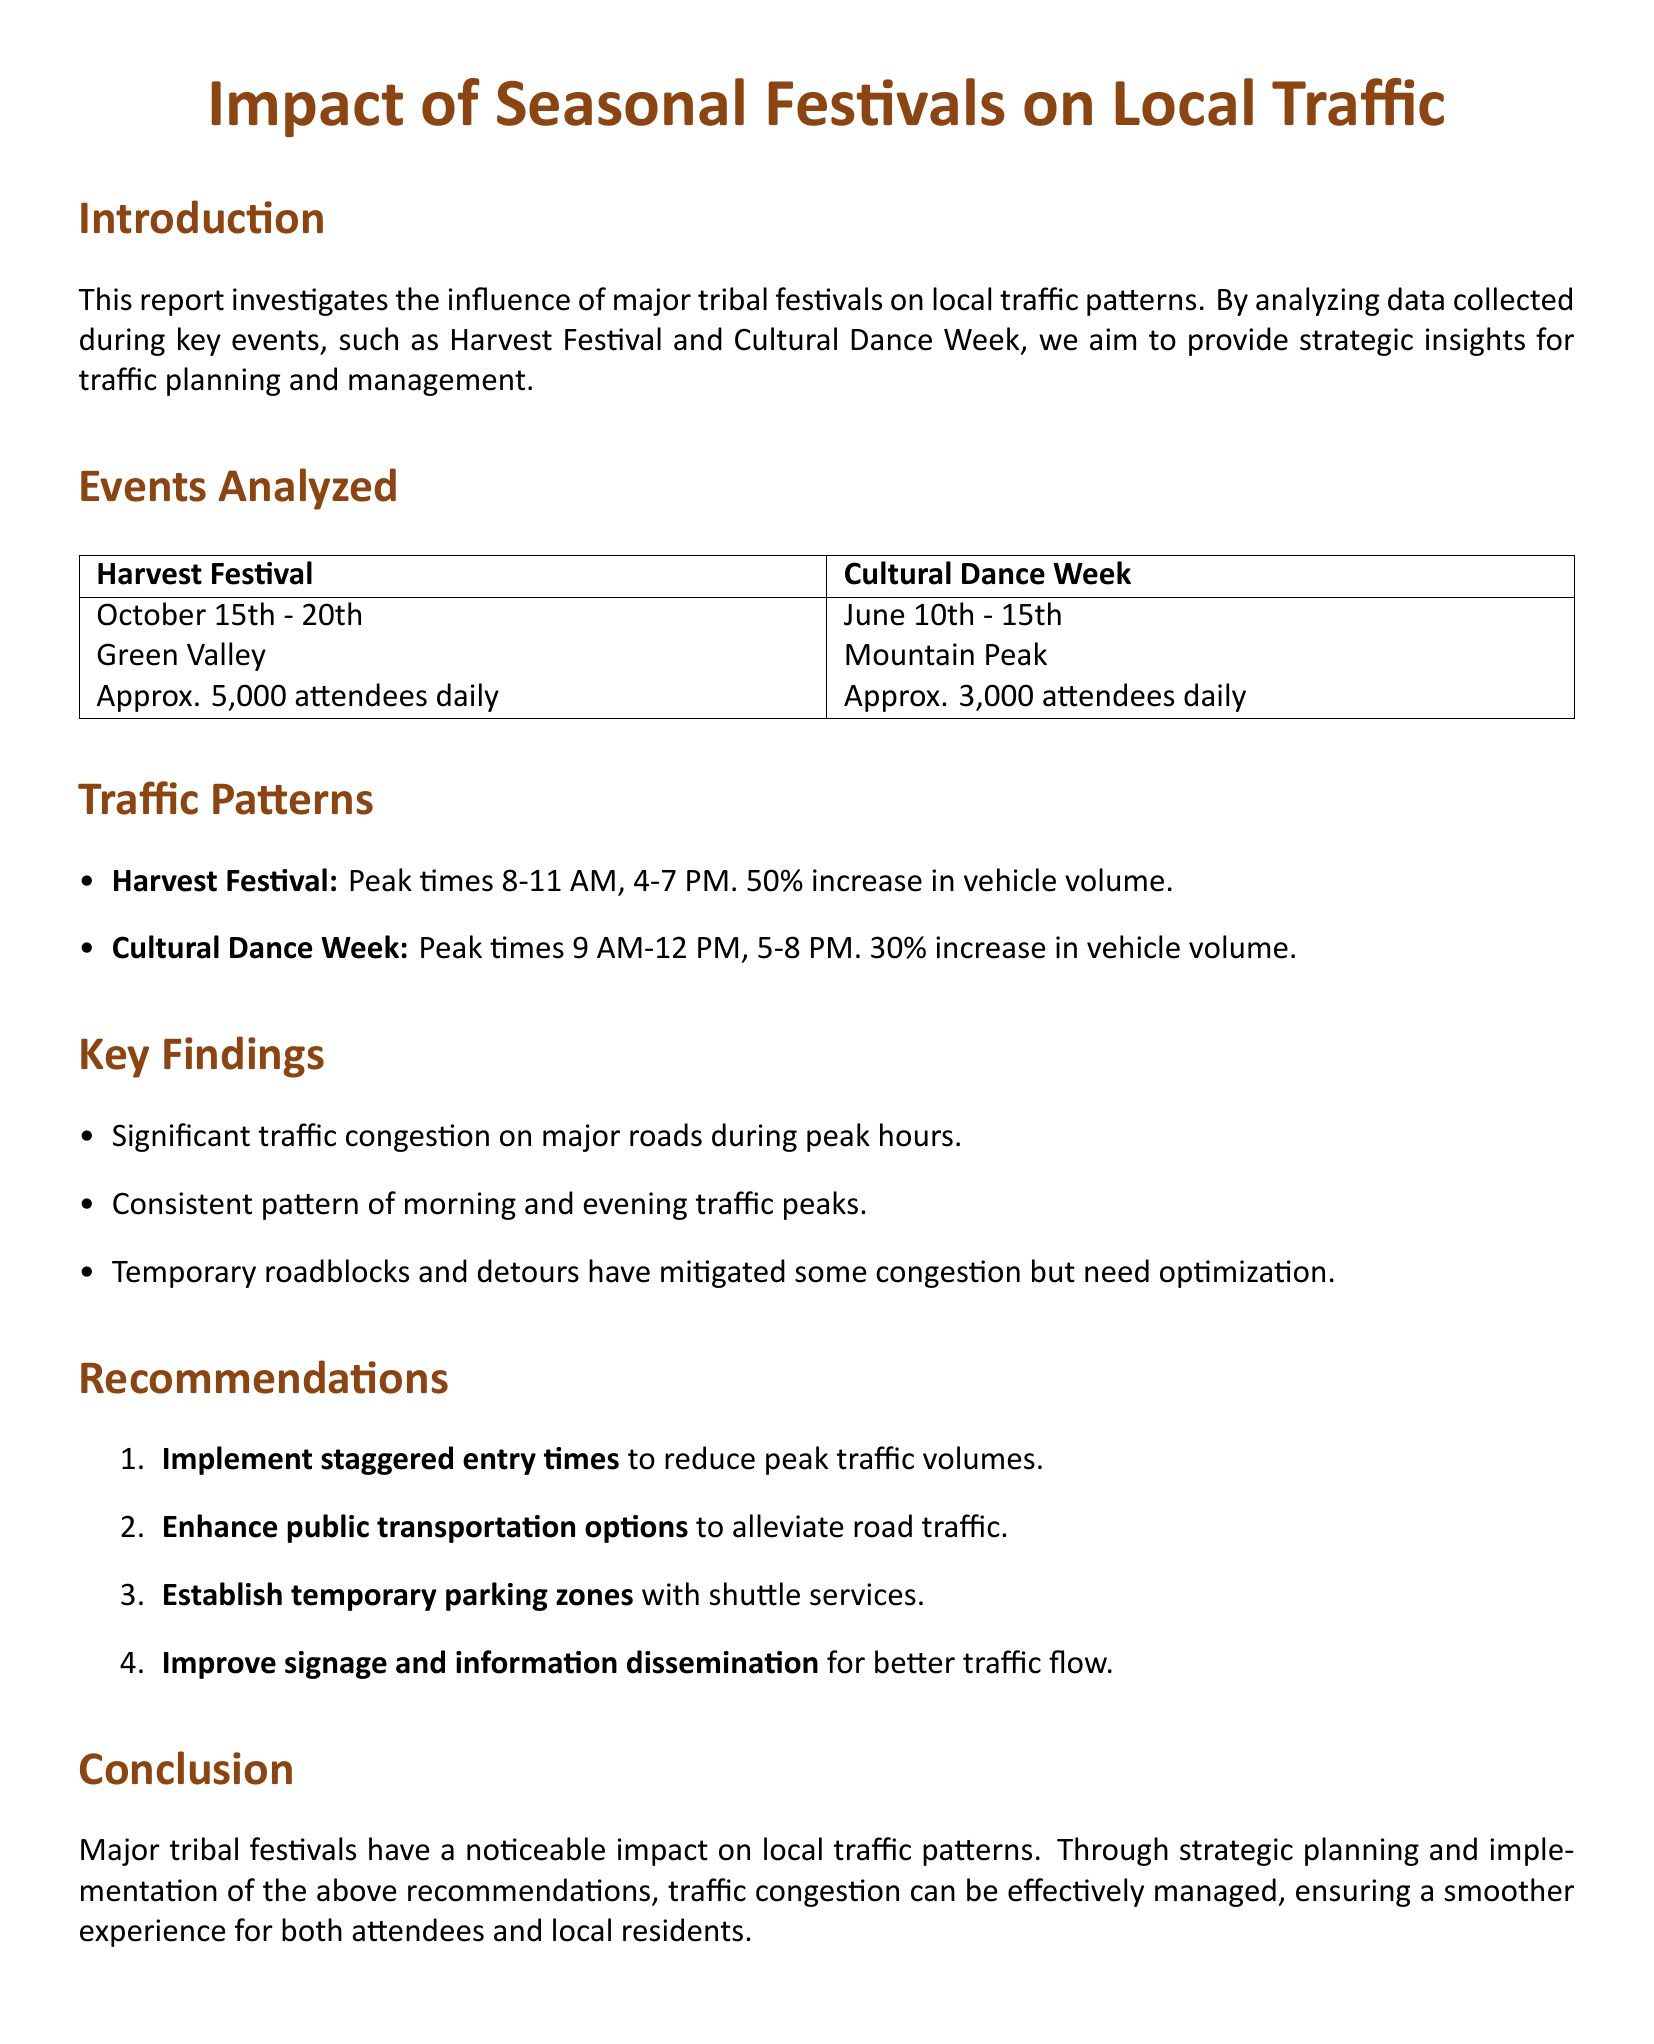What are the dates of the Harvest Festival? The document states that the Harvest Festival occurs from October 15th to 20th.
Answer: October 15th - 20th How many attendees are expected daily during the Cultural Dance Week? According to the report, approximately 3,000 attendees are expected daily during the Cultural Dance Week.
Answer: Approx. 3,000 attendees daily What is the peak time for traffic during the Harvest Festival? The report indicates that the peak traffic times during the Harvest Festival are between 8-11 AM and 4-7 PM.
Answer: 8-11 AM, 4-7 PM What percentage increase in vehicle volume is observed during the Cultural Dance Week? The report notes a 30% increase in vehicle volume during the Cultural Dance Week.
Answer: 30% What is a recommended strategy for reducing traffic? The document recommends implementing staggered entry times to reduce peak traffic volumes.
Answer: Staggered entry times What significant issue is reported during major tribal events? The report highlights significant traffic congestion on major roads during peak hours.
Answer: Traffic congestion Which festival has a higher daily attendance? The document specifies that the Harvest Festival has approximately 5,000 attendees daily, which is higher than the Cultural Dance Week.
Answer: Harvest Festival What type of transportation enhancement is suggested? The report suggests enhancing public transportation options to alleviate road traffic.
Answer: Public transportation options What does the report conclude about the impact of major tribal festivals? The conclusion states that major tribal festivals have a noticeable impact on local traffic patterns.
Answer: Noticeable impact 